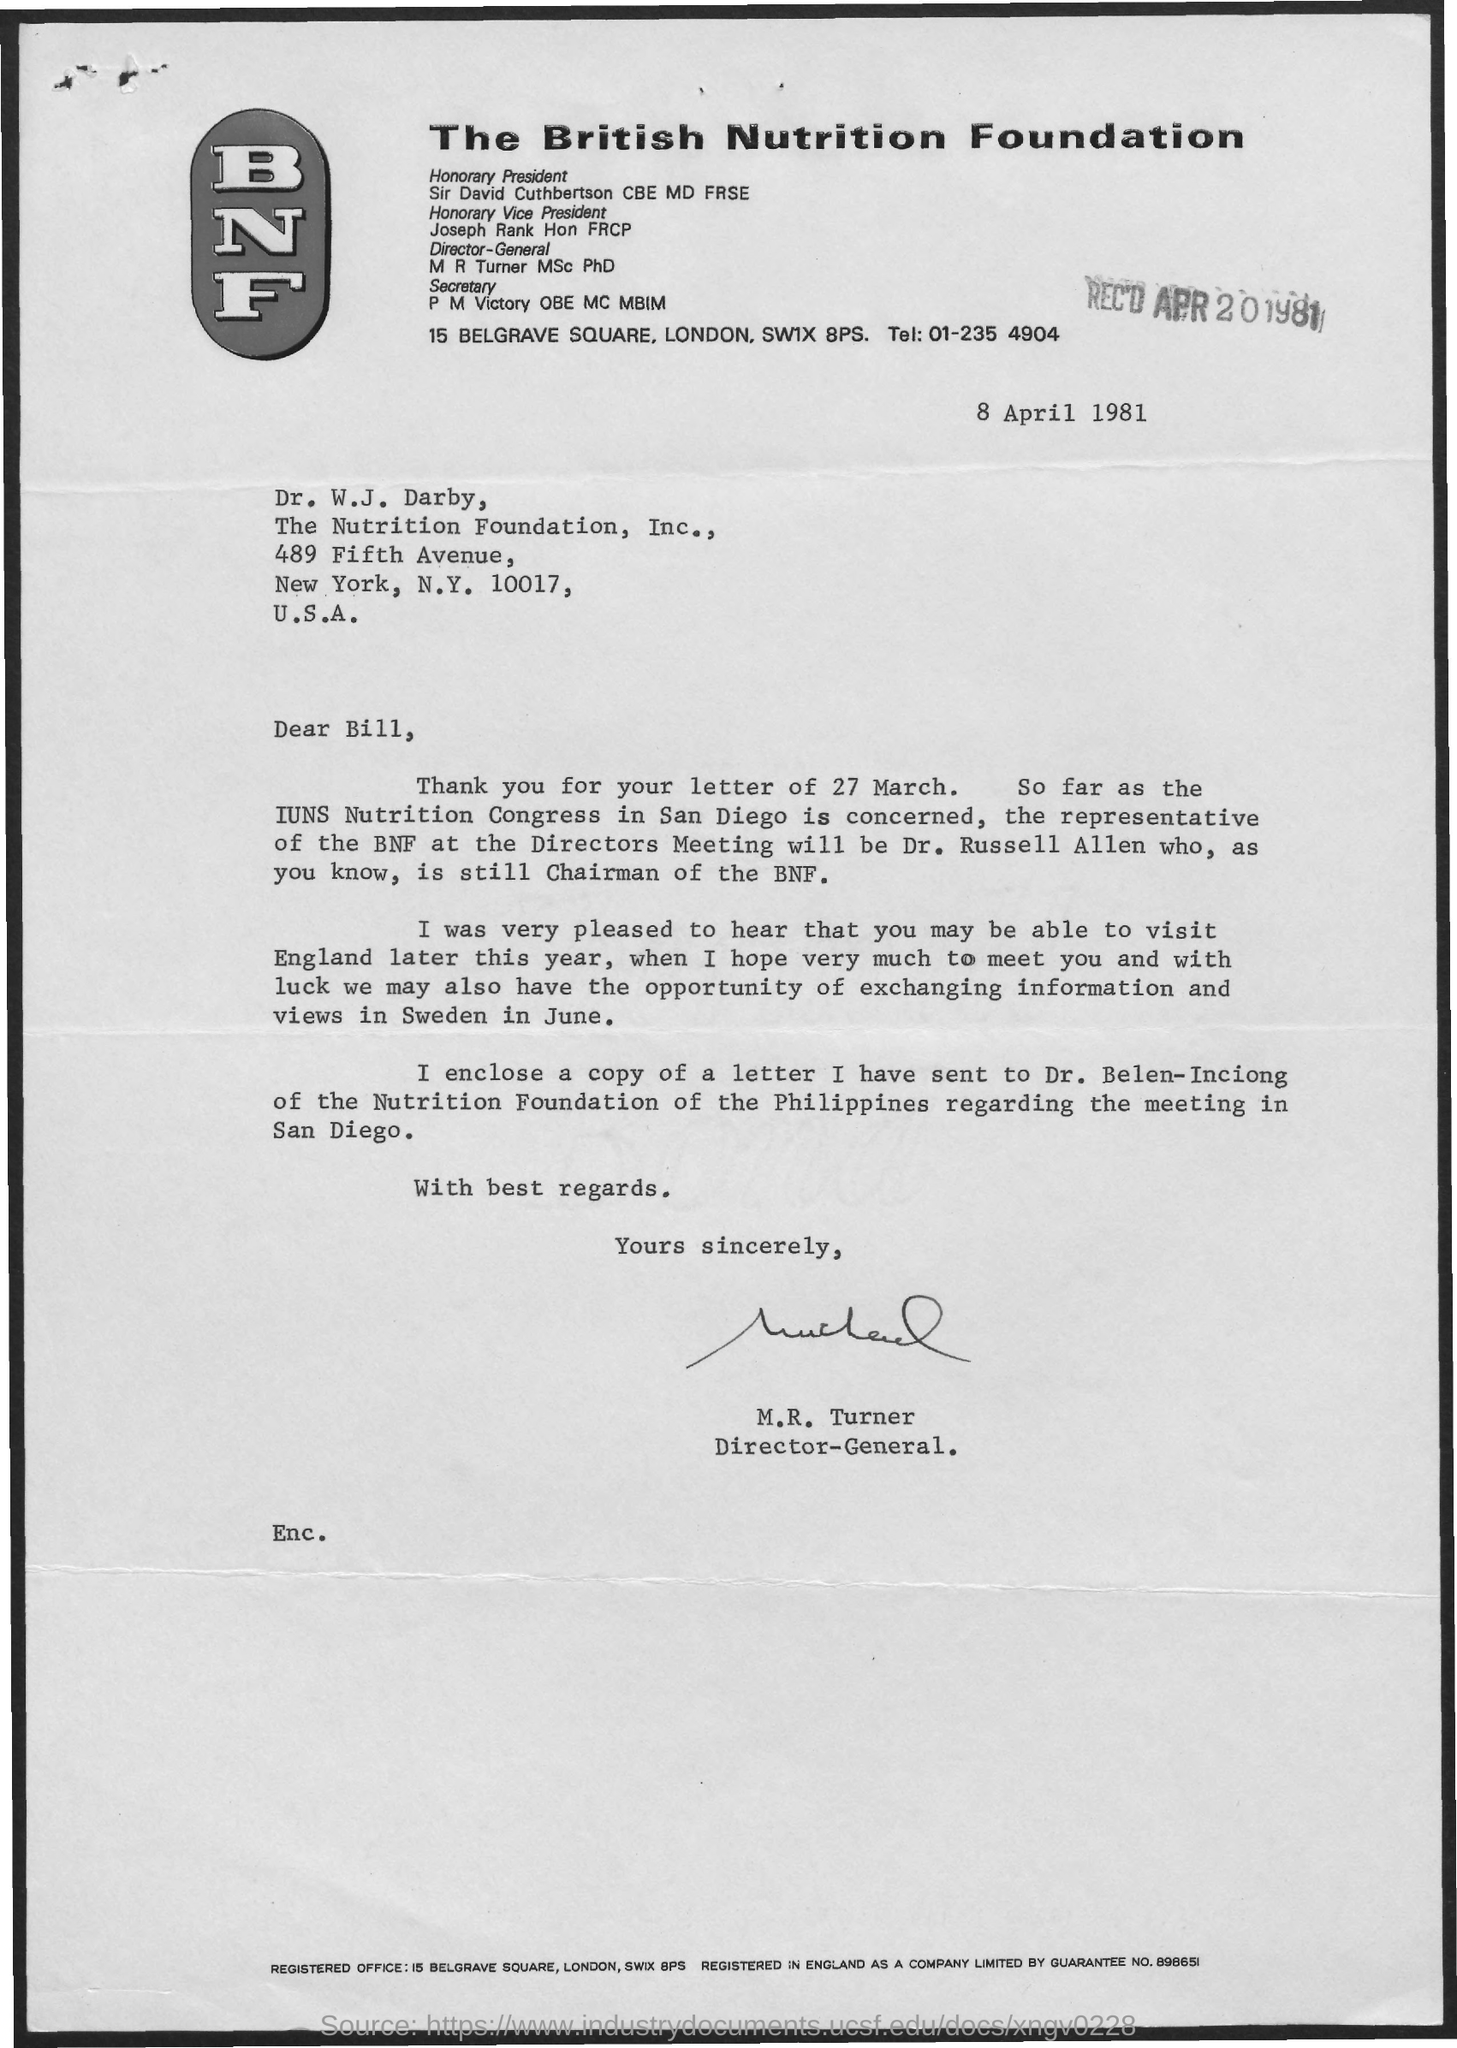What is the date on the document?
Keep it short and to the point. 8 April 1981. When was the letter received?
Offer a very short reply. Apr 20 1981. To whom is this letter addressed to?
Keep it short and to the point. Bill. Who is this letter from?
Offer a terse response. M.R. Turner. 